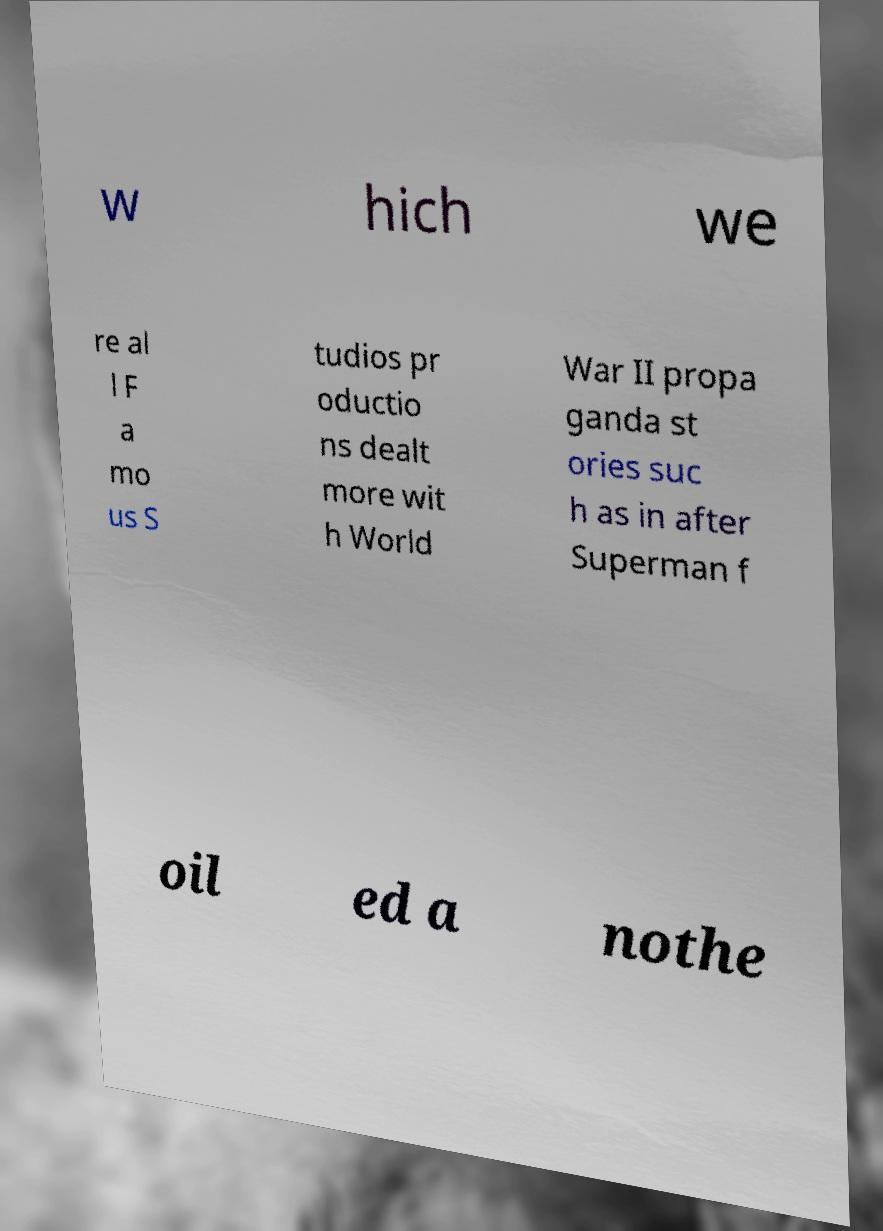Can you read and provide the text displayed in the image?This photo seems to have some interesting text. Can you extract and type it out for me? w hich we re al l F a mo us S tudios pr oductio ns dealt more wit h World War II propa ganda st ories suc h as in after Superman f oil ed a nothe 